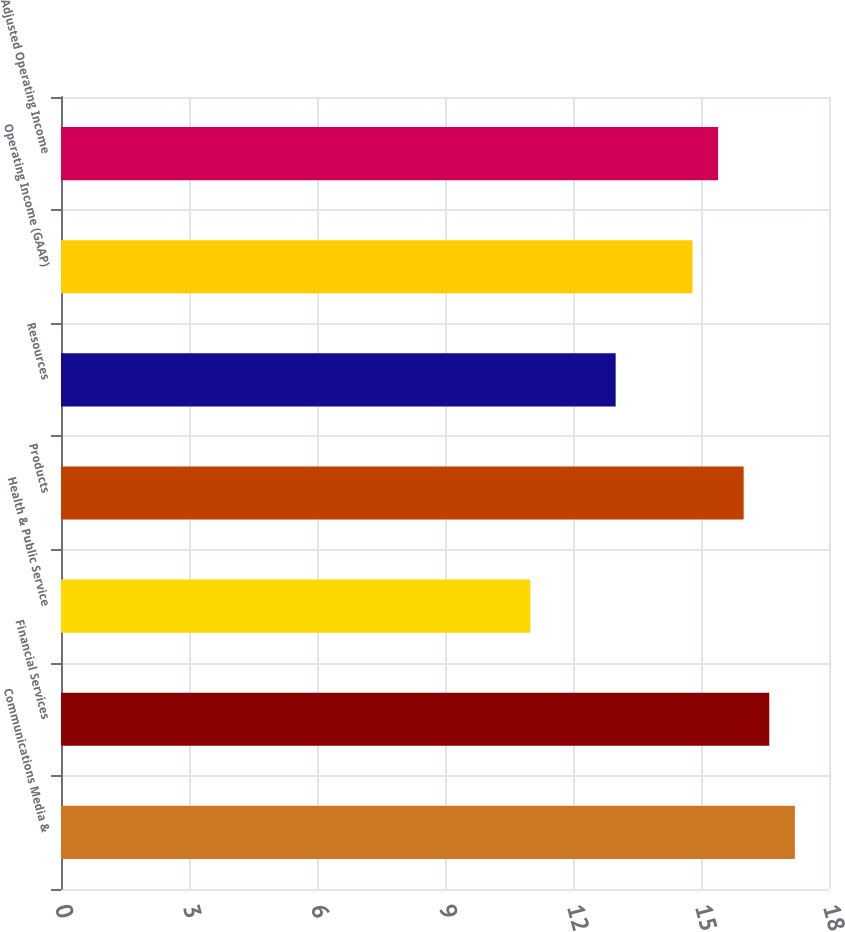Convert chart. <chart><loc_0><loc_0><loc_500><loc_500><bar_chart><fcel>Communications Media &<fcel>Financial Services<fcel>Health & Public Service<fcel>Products<fcel>Resources<fcel>Operating Income (GAAP)<fcel>Adjusted Operating Income<nl><fcel>17.2<fcel>16.6<fcel>11<fcel>16<fcel>13<fcel>14.8<fcel>15.4<nl></chart> 